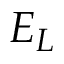<formula> <loc_0><loc_0><loc_500><loc_500>E _ { L }</formula> 